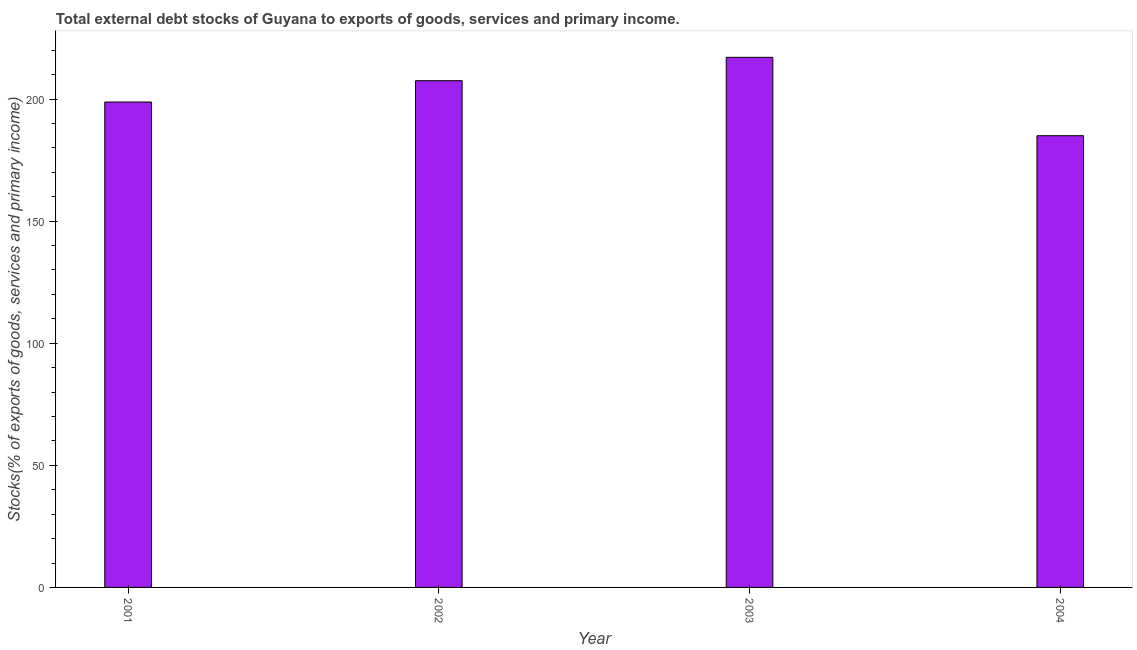Does the graph contain any zero values?
Offer a terse response. No. What is the title of the graph?
Your answer should be very brief. Total external debt stocks of Guyana to exports of goods, services and primary income. What is the label or title of the Y-axis?
Your response must be concise. Stocks(% of exports of goods, services and primary income). What is the external debt stocks in 2001?
Your answer should be very brief. 198.77. Across all years, what is the maximum external debt stocks?
Ensure brevity in your answer.  217.07. Across all years, what is the minimum external debt stocks?
Make the answer very short. 184.98. In which year was the external debt stocks maximum?
Keep it short and to the point. 2003. What is the sum of the external debt stocks?
Keep it short and to the point. 808.32. What is the difference between the external debt stocks in 2001 and 2003?
Keep it short and to the point. -18.3. What is the average external debt stocks per year?
Offer a very short reply. 202.08. What is the median external debt stocks?
Provide a short and direct response. 203.13. In how many years, is the external debt stocks greater than 150 %?
Your answer should be very brief. 4. Do a majority of the years between 2002 and 2003 (inclusive) have external debt stocks greater than 70 %?
Provide a short and direct response. Yes. What is the ratio of the external debt stocks in 2001 to that in 2004?
Offer a very short reply. 1.07. Is the external debt stocks in 2003 less than that in 2004?
Provide a short and direct response. No. Is the difference between the external debt stocks in 2001 and 2002 greater than the difference between any two years?
Offer a very short reply. No. What is the difference between the highest and the second highest external debt stocks?
Make the answer very short. 9.57. What is the difference between the highest and the lowest external debt stocks?
Make the answer very short. 32.09. How many bars are there?
Your response must be concise. 4. How many years are there in the graph?
Ensure brevity in your answer.  4. What is the difference between two consecutive major ticks on the Y-axis?
Provide a succinct answer. 50. What is the Stocks(% of exports of goods, services and primary income) in 2001?
Provide a short and direct response. 198.77. What is the Stocks(% of exports of goods, services and primary income) in 2002?
Provide a succinct answer. 207.5. What is the Stocks(% of exports of goods, services and primary income) of 2003?
Keep it short and to the point. 217.07. What is the Stocks(% of exports of goods, services and primary income) in 2004?
Keep it short and to the point. 184.98. What is the difference between the Stocks(% of exports of goods, services and primary income) in 2001 and 2002?
Give a very brief answer. -8.73. What is the difference between the Stocks(% of exports of goods, services and primary income) in 2001 and 2003?
Your answer should be very brief. -18.3. What is the difference between the Stocks(% of exports of goods, services and primary income) in 2001 and 2004?
Provide a succinct answer. 13.79. What is the difference between the Stocks(% of exports of goods, services and primary income) in 2002 and 2003?
Provide a succinct answer. -9.57. What is the difference between the Stocks(% of exports of goods, services and primary income) in 2002 and 2004?
Make the answer very short. 22.52. What is the difference between the Stocks(% of exports of goods, services and primary income) in 2003 and 2004?
Offer a terse response. 32.09. What is the ratio of the Stocks(% of exports of goods, services and primary income) in 2001 to that in 2002?
Your answer should be compact. 0.96. What is the ratio of the Stocks(% of exports of goods, services and primary income) in 2001 to that in 2003?
Keep it short and to the point. 0.92. What is the ratio of the Stocks(% of exports of goods, services and primary income) in 2001 to that in 2004?
Your answer should be compact. 1.07. What is the ratio of the Stocks(% of exports of goods, services and primary income) in 2002 to that in 2003?
Your answer should be very brief. 0.96. What is the ratio of the Stocks(% of exports of goods, services and primary income) in 2002 to that in 2004?
Offer a very short reply. 1.12. What is the ratio of the Stocks(% of exports of goods, services and primary income) in 2003 to that in 2004?
Your response must be concise. 1.17. 